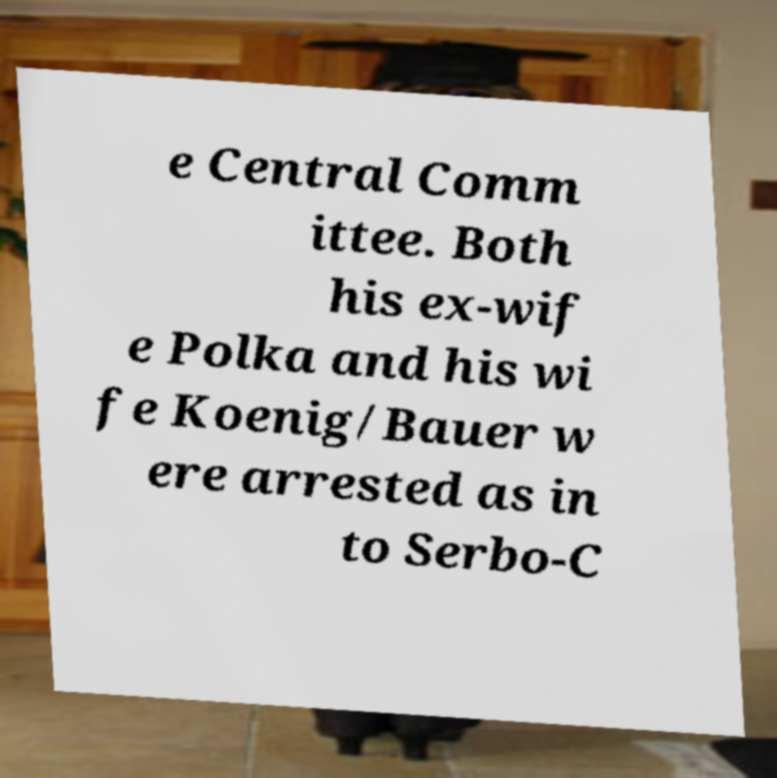Could you assist in decoding the text presented in this image and type it out clearly? e Central Comm ittee. Both his ex-wif e Polka and his wi fe Koenig/Bauer w ere arrested as in to Serbo-C 